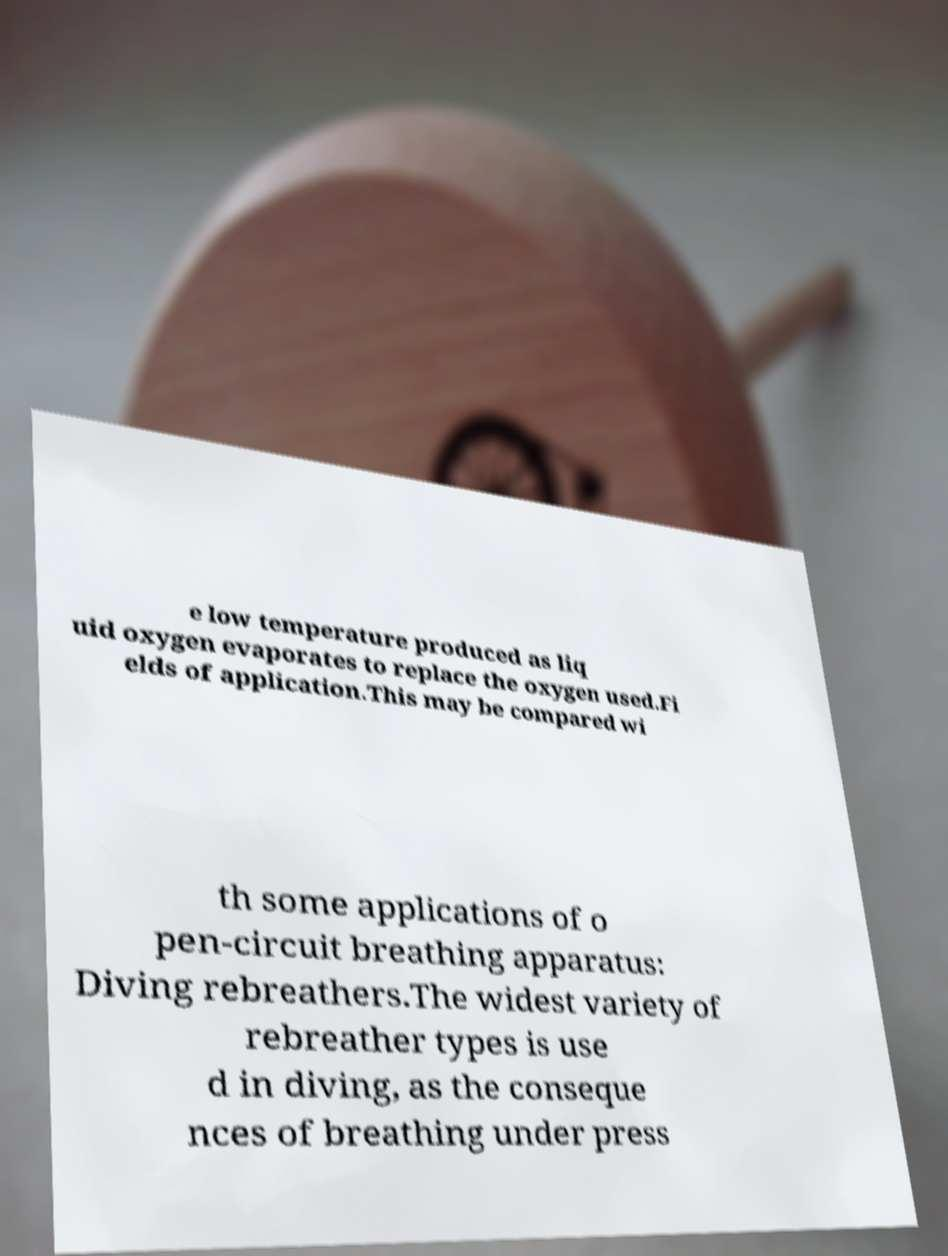For documentation purposes, I need the text within this image transcribed. Could you provide that? e low temperature produced as liq uid oxygen evaporates to replace the oxygen used.Fi elds of application.This may be compared wi th some applications of o pen-circuit breathing apparatus: Diving rebreathers.The widest variety of rebreather types is use d in diving, as the conseque nces of breathing under press 